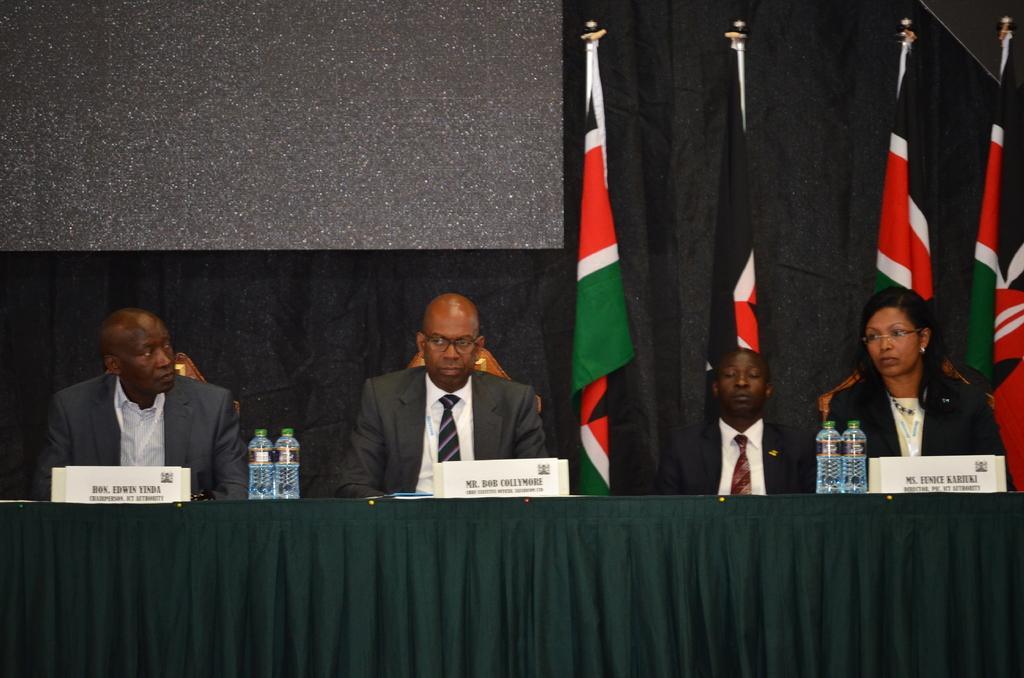In one or two sentences, can you explain what this image depicts? In this picture, we can see a group of people sitting on chairs and in front of these people there is a table and the table is covered with a cloth. On the table there are name boards and water bottles. Behind the people there are flags and a black cloth. 